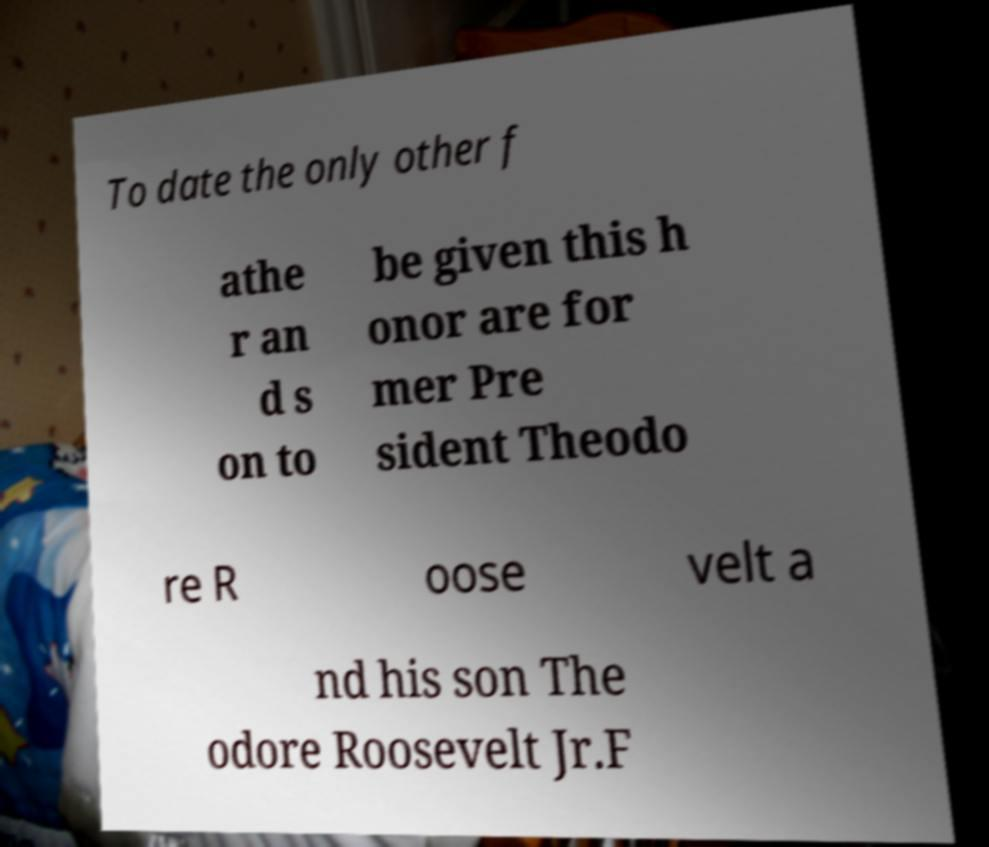For documentation purposes, I need the text within this image transcribed. Could you provide that? To date the only other f athe r an d s on to be given this h onor are for mer Pre sident Theodo re R oose velt a nd his son The odore Roosevelt Jr.F 